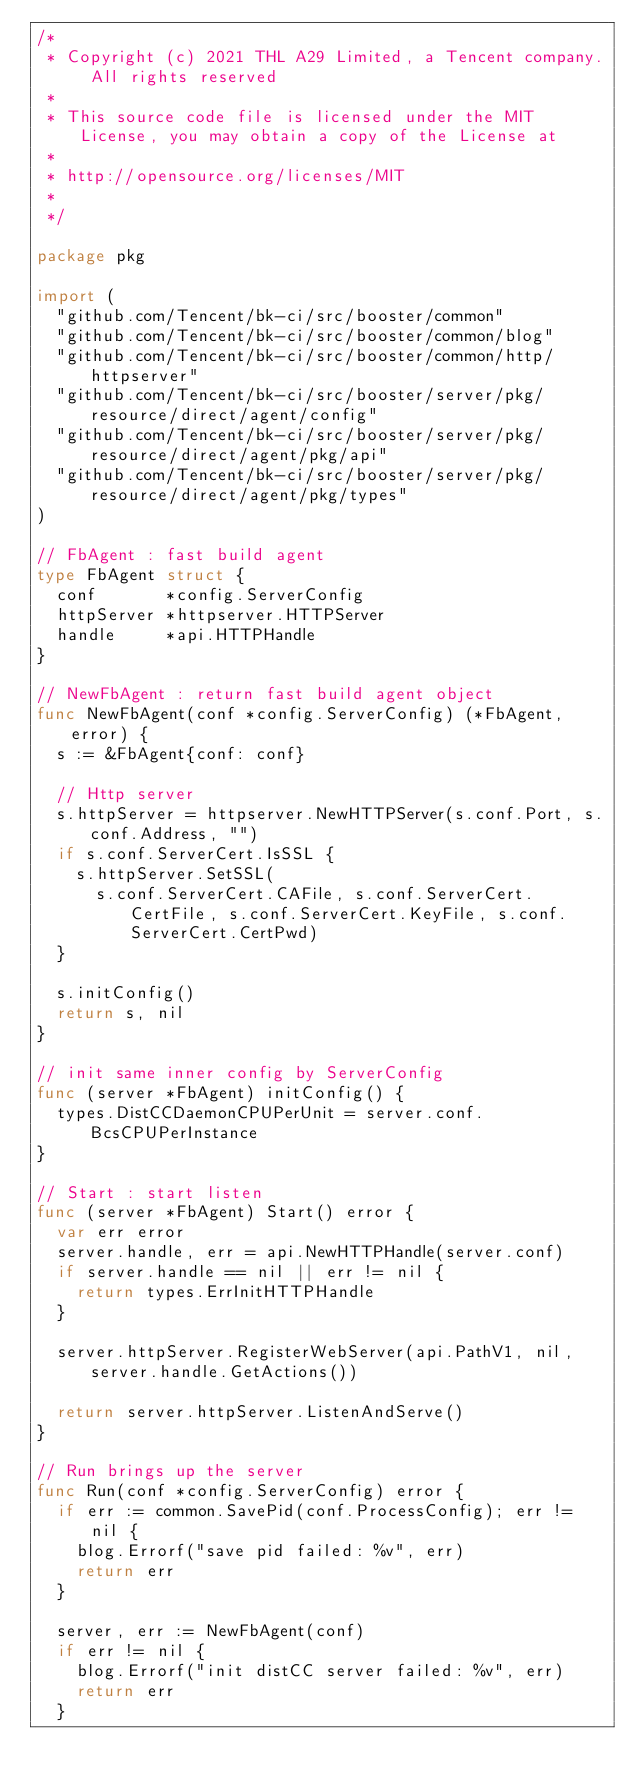Convert code to text. <code><loc_0><loc_0><loc_500><loc_500><_Go_>/*
 * Copyright (c) 2021 THL A29 Limited, a Tencent company. All rights reserved
 *
 * This source code file is licensed under the MIT License, you may obtain a copy of the License at
 *
 * http://opensource.org/licenses/MIT
 *
 */

package pkg

import (
	"github.com/Tencent/bk-ci/src/booster/common"
	"github.com/Tencent/bk-ci/src/booster/common/blog"
	"github.com/Tencent/bk-ci/src/booster/common/http/httpserver"
	"github.com/Tencent/bk-ci/src/booster/server/pkg/resource/direct/agent/config"
	"github.com/Tencent/bk-ci/src/booster/server/pkg/resource/direct/agent/pkg/api"
	"github.com/Tencent/bk-ci/src/booster/server/pkg/resource/direct/agent/pkg/types"
)

// FbAgent : fast build agent
type FbAgent struct {
	conf       *config.ServerConfig
	httpServer *httpserver.HTTPServer
	handle     *api.HTTPHandle
}

// NewFbAgent : return fast build agent object
func NewFbAgent(conf *config.ServerConfig) (*FbAgent, error) {
	s := &FbAgent{conf: conf}

	// Http server
	s.httpServer = httpserver.NewHTTPServer(s.conf.Port, s.conf.Address, "")
	if s.conf.ServerCert.IsSSL {
		s.httpServer.SetSSL(
			s.conf.ServerCert.CAFile, s.conf.ServerCert.CertFile, s.conf.ServerCert.KeyFile, s.conf.ServerCert.CertPwd)
	}

	s.initConfig()
	return s, nil
}

// init same inner config by ServerConfig
func (server *FbAgent) initConfig() {
	types.DistCCDaemonCPUPerUnit = server.conf.BcsCPUPerInstance
}

// Start : start listen
func (server *FbAgent) Start() error {
	var err error
	server.handle, err = api.NewHTTPHandle(server.conf)
	if server.handle == nil || err != nil {
		return types.ErrInitHTTPHandle
	}

	server.httpServer.RegisterWebServer(api.PathV1, nil, server.handle.GetActions())

	return server.httpServer.ListenAndServe()
}

// Run brings up the server
func Run(conf *config.ServerConfig) error {
	if err := common.SavePid(conf.ProcessConfig); err != nil {
		blog.Errorf("save pid failed: %v", err)
		return err
	}

	server, err := NewFbAgent(conf)
	if err != nil {
		blog.Errorf("init distCC server failed: %v", err)
		return err
	}
</code> 